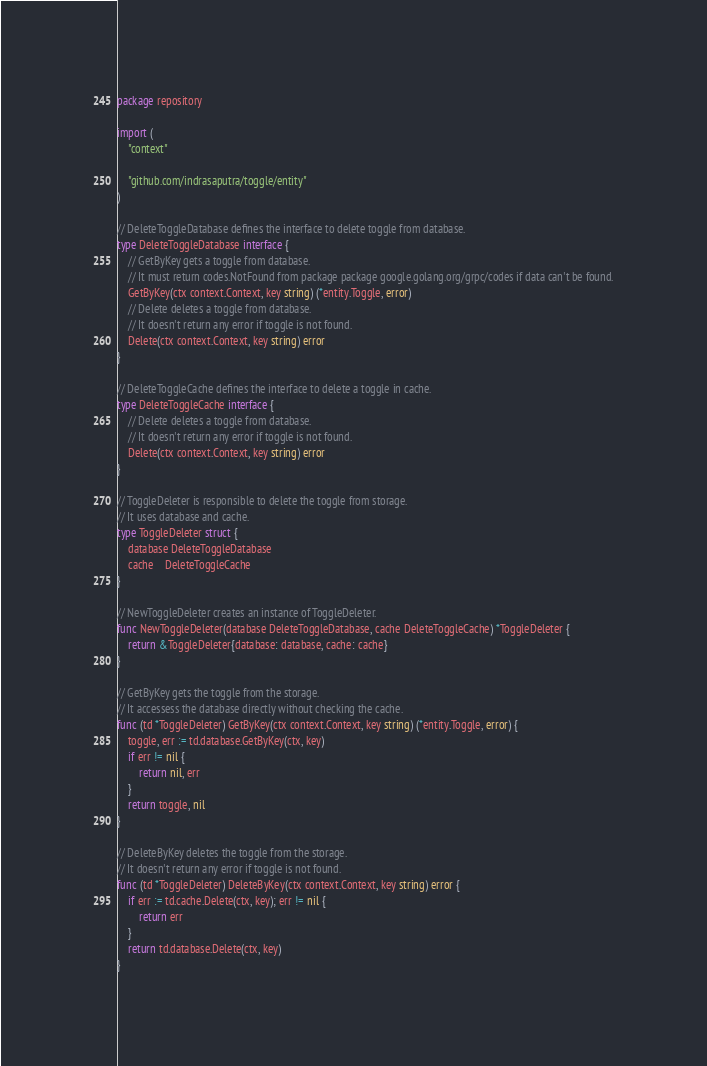Convert code to text. <code><loc_0><loc_0><loc_500><loc_500><_Go_>package repository

import (
	"context"

	"github.com/indrasaputra/toggle/entity"
)

// DeleteToggleDatabase defines the interface to delete toggle from database.
type DeleteToggleDatabase interface {
	// GetByKey gets a toggle from database.
	// It must return codes.NotFound from package package google.golang.org/grpc/codes if data can't be found.
	GetByKey(ctx context.Context, key string) (*entity.Toggle, error)
	// Delete deletes a toggle from database.
	// It doesn't return any error if toggle is not found.
	Delete(ctx context.Context, key string) error
}

// DeleteToggleCache defines the interface to delete a toggle in cache.
type DeleteToggleCache interface {
	// Delete deletes a toggle from database.
	// It doesn't return any error if toggle is not found.
	Delete(ctx context.Context, key string) error
}

// ToggleDeleter is responsible to delete the toggle from storage.
// It uses database and cache.
type ToggleDeleter struct {
	database DeleteToggleDatabase
	cache    DeleteToggleCache
}

// NewToggleDeleter creates an instance of ToggleDeleter.
func NewToggleDeleter(database DeleteToggleDatabase, cache DeleteToggleCache) *ToggleDeleter {
	return &ToggleDeleter{database: database, cache: cache}
}

// GetByKey gets the toggle from the storage.
// It accessess the database directly without checking the cache.
func (td *ToggleDeleter) GetByKey(ctx context.Context, key string) (*entity.Toggle, error) {
	toggle, err := td.database.GetByKey(ctx, key)
	if err != nil {
		return nil, err
	}
	return toggle, nil
}

// DeleteByKey deletes the toggle from the storage.
// It doesn't return any error if toggle is not found.
func (td *ToggleDeleter) DeleteByKey(ctx context.Context, key string) error {
	if err := td.cache.Delete(ctx, key); err != nil {
		return err
	}
	return td.database.Delete(ctx, key)
}
</code> 